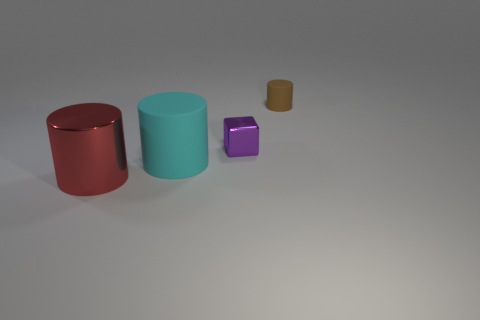Subtract all matte cylinders. How many cylinders are left? 1 Add 3 gray metallic blocks. How many objects exist? 7 Subtract all cylinders. How many objects are left? 1 Subtract all tiny cyan cylinders. Subtract all tiny brown matte cylinders. How many objects are left? 3 Add 2 small brown cylinders. How many small brown cylinders are left? 3 Add 2 large shiny cylinders. How many large shiny cylinders exist? 3 Subtract 1 purple blocks. How many objects are left? 3 